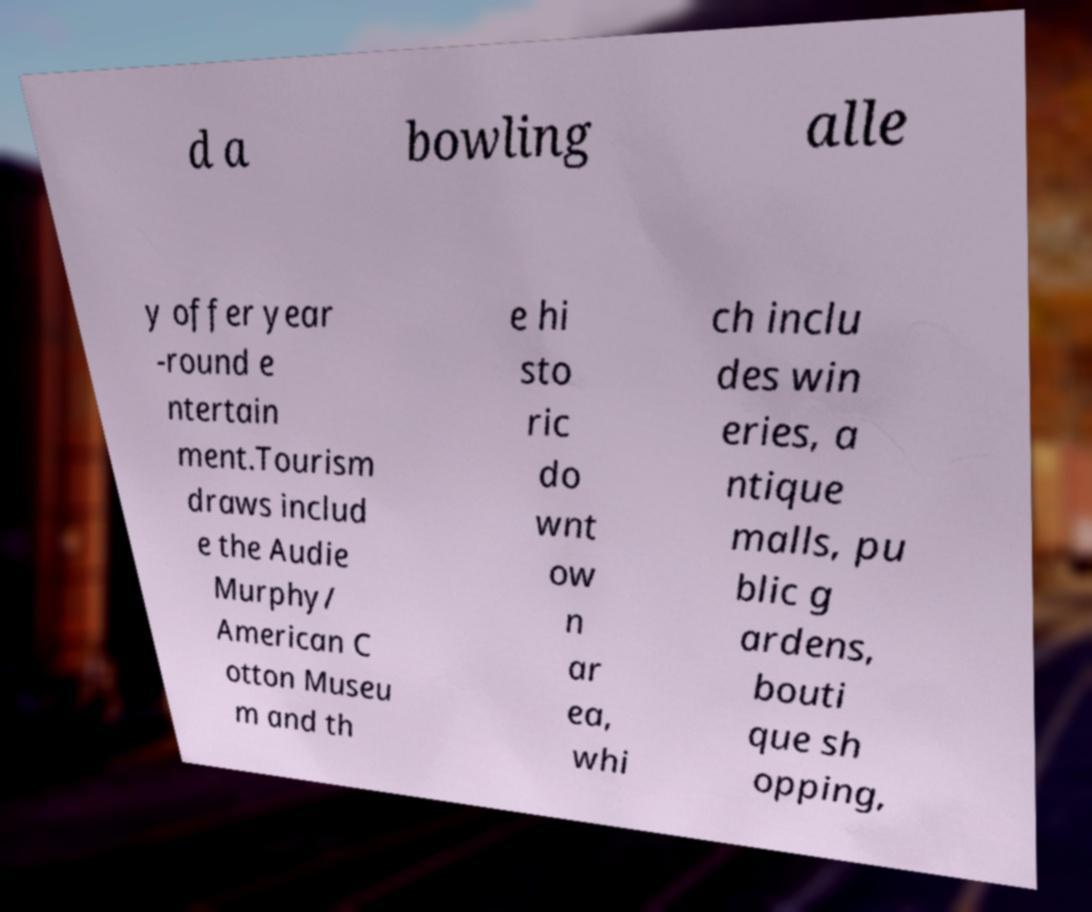Could you extract and type out the text from this image? d a bowling alle y offer year -round e ntertain ment.Tourism draws includ e the Audie Murphy/ American C otton Museu m and th e hi sto ric do wnt ow n ar ea, whi ch inclu des win eries, a ntique malls, pu blic g ardens, bouti que sh opping, 